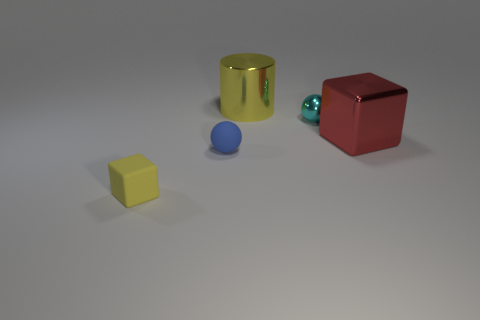Add 2 gray cubes. How many objects exist? 7 Subtract all blocks. How many objects are left? 3 Subtract all blue spheres. How many spheres are left? 1 Subtract 1 cubes. How many cubes are left? 1 Subtract all tiny brown matte cubes. Subtract all red metal things. How many objects are left? 4 Add 2 big yellow cylinders. How many big yellow cylinders are left? 3 Add 1 red cubes. How many red cubes exist? 2 Subtract 0 gray balls. How many objects are left? 5 Subtract all yellow cubes. Subtract all blue cylinders. How many cubes are left? 1 